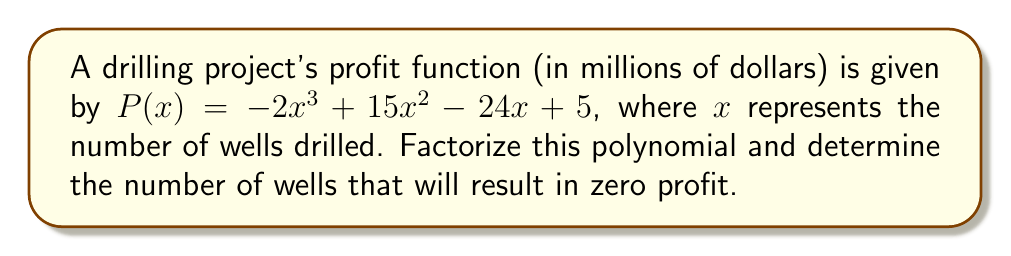Could you help me with this problem? To solve this problem, we need to factorize the polynomial $P(x) = -2x^3 + 15x^2 - 24x + 5$ and find the roots.

Step 1: Factor out the greatest common factor (GCF)
$P(x) = -1(2x^3 - 15x^2 + 24x - 5)$

Step 2: Try to guess one root. In this case, $x = 1$ is a root.
$P(1) = -2(1)^3 + 15(1)^2 - 24(1) + 5 = -2 + 15 - 24 + 5 = -6 + 5 = -1 + 1 = 0$

Step 3: Divide the polynomial by $(x - 1)$ using synthetic division:

$$
\begin{array}{r|rrrr}
1 & -2 & 15 & -24 & 5 \\
& -2 & 13 & -11 \\
\hline
& -2 & 13 & -11 & 5
\end{array}
$$

Step 4: The result of the division is $-2x^2 + 13x - 11$

Step 5: Factor the quadratic expression $-2x^2 + 13x - 11$
$-2x^2 + 13x - 11 = -(2x^2 - 13x + 11) = -(2x - 1)(x - 6)$

Step 6: Combine all factors
$P(x) = -1(x - 1)(2x - 1)(x - 6)$

The roots of this polynomial are $x = 1$, $x = \frac{1}{2}$, and $x = 6$. However, since we're dealing with the number of wells, which must be a positive integer, the only relevant solution is $x = 1$.

Therefore, drilling 1 well will result in zero profit for this project.
Answer: 1 well 